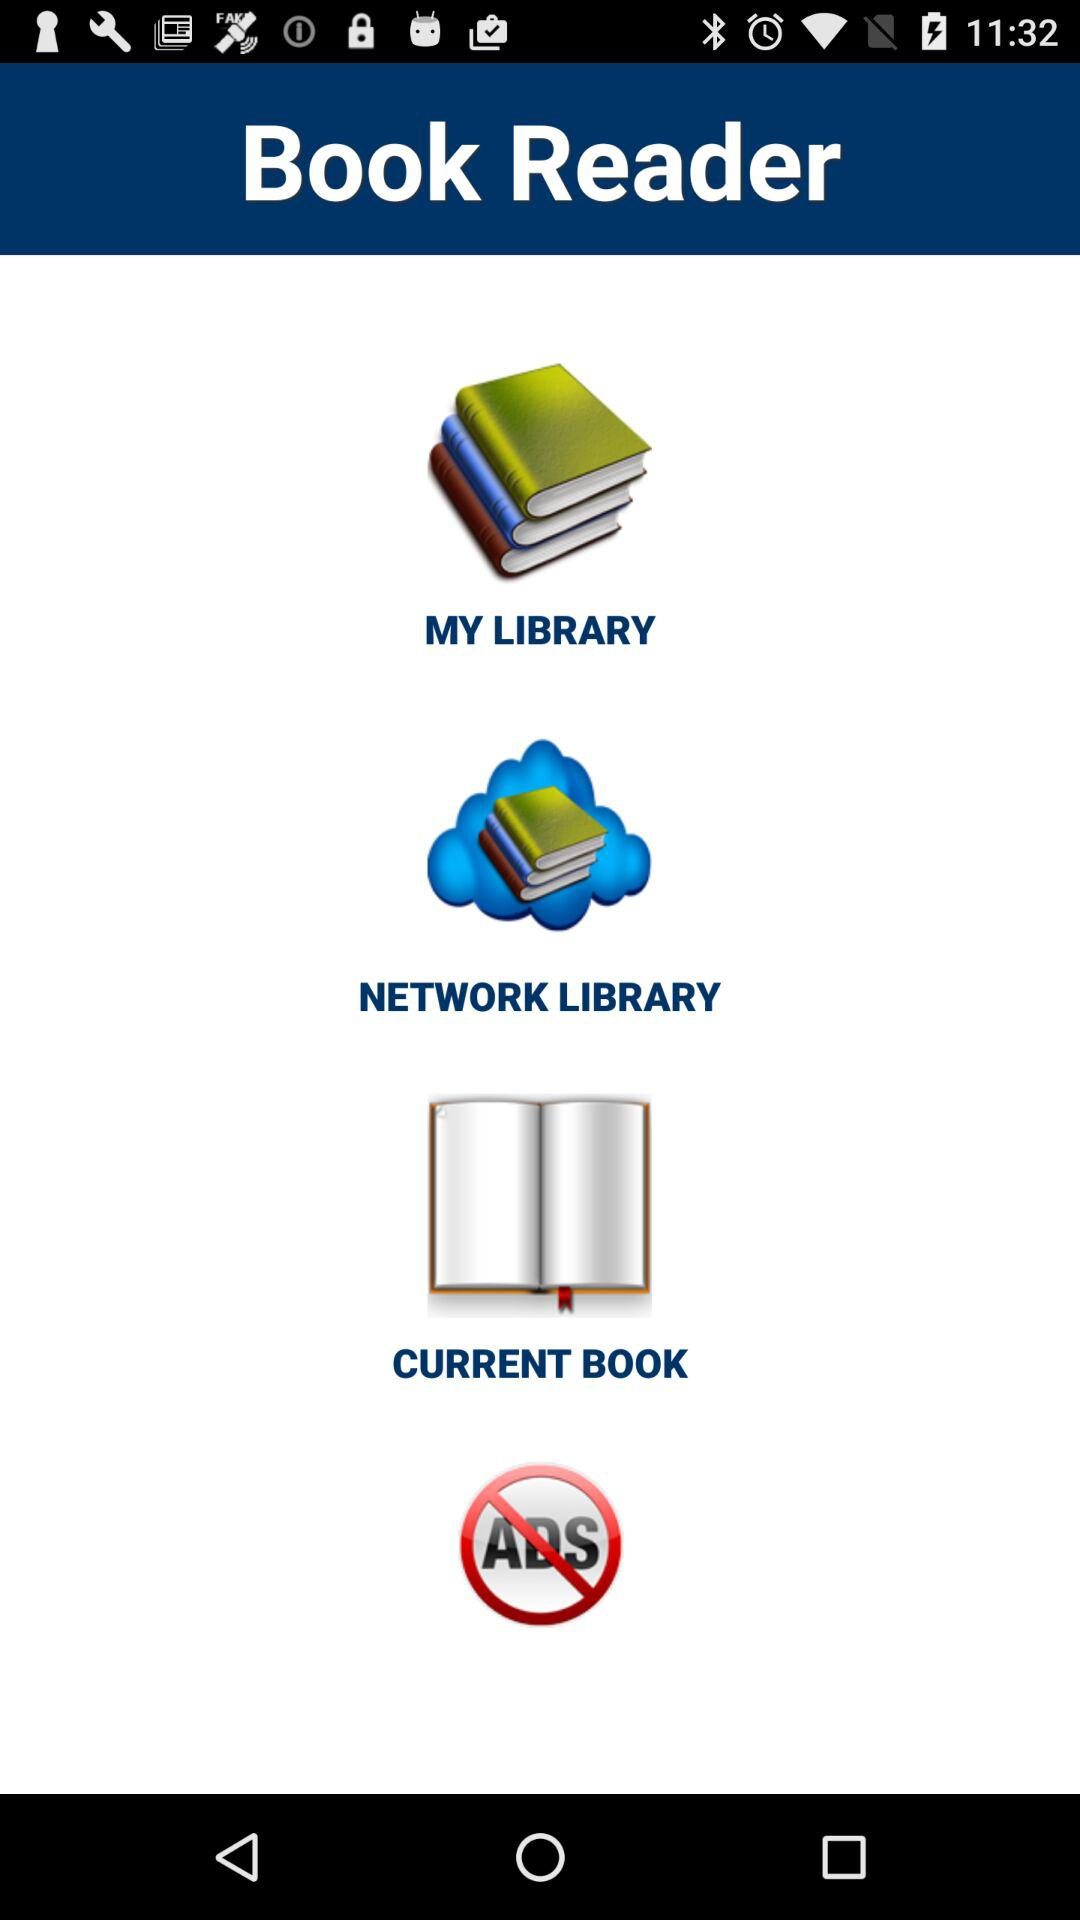What is the application name? The application name is "Book Reader". 